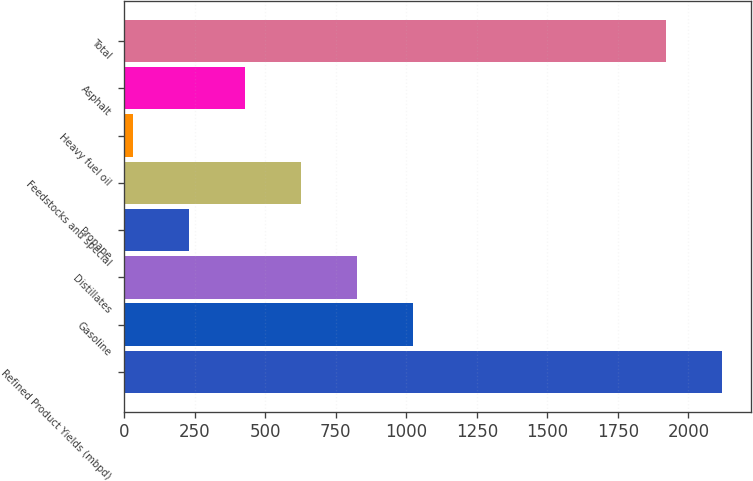Convert chart. <chart><loc_0><loc_0><loc_500><loc_500><bar_chart><fcel>Refined Product Yields (mbpd)<fcel>Gasoline<fcel>Distillates<fcel>Propane<fcel>Feedstocks and special<fcel>Heavy fuel oil<fcel>Asphalt<fcel>Total<nl><fcel>2117.4<fcel>1023<fcel>824.6<fcel>229.4<fcel>626.2<fcel>31<fcel>427.8<fcel>1919<nl></chart> 